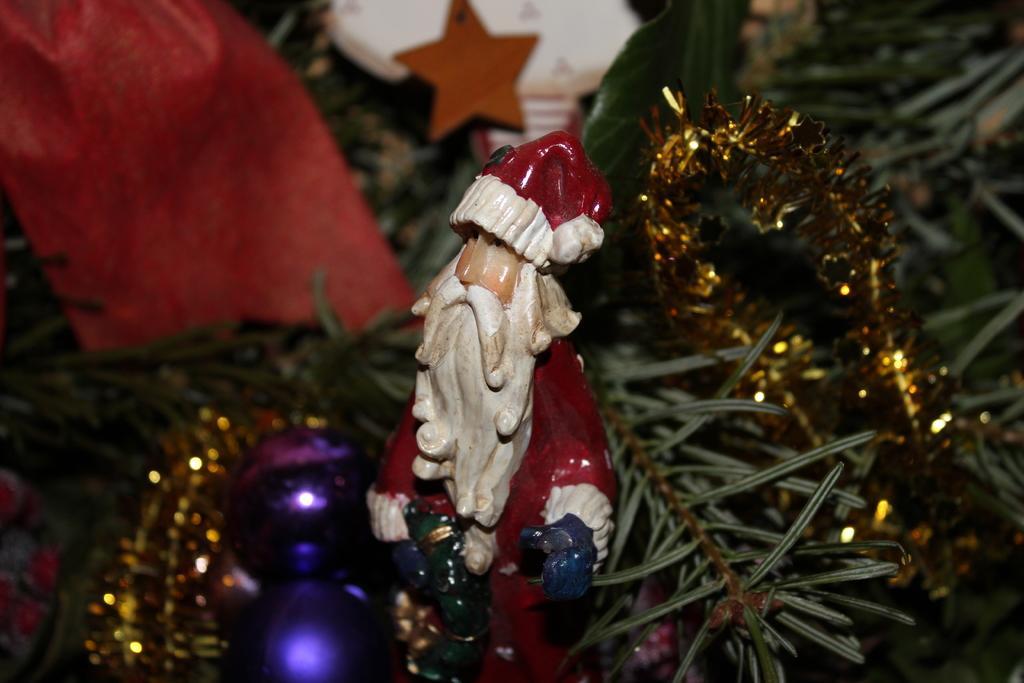Can you describe this image briefly? In this image I can see a statue of a Santa Claus which is red, white and cream in color and I can see few decorative items, a tree and a light. 